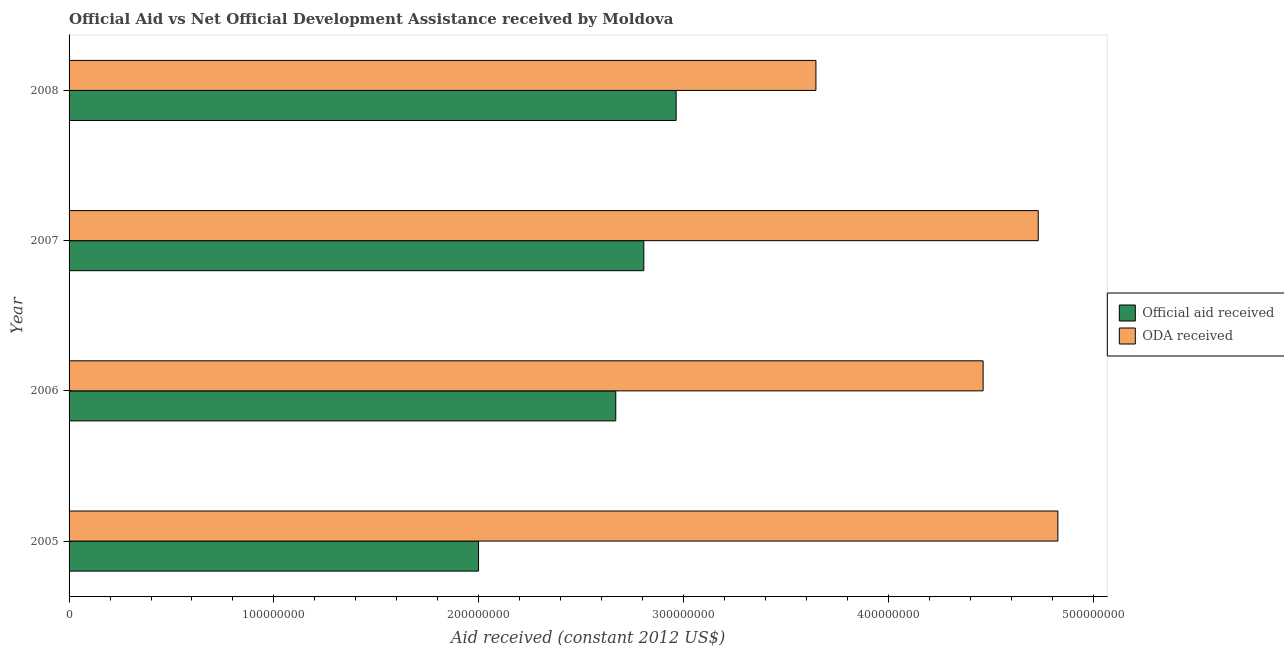How many different coloured bars are there?
Your answer should be compact. 2. How many groups of bars are there?
Your answer should be compact. 4. How many bars are there on the 4th tick from the top?
Your answer should be compact. 2. What is the oda received in 2005?
Make the answer very short. 4.83e+08. Across all years, what is the maximum official aid received?
Provide a succinct answer. 2.96e+08. Across all years, what is the minimum oda received?
Provide a succinct answer. 3.65e+08. In which year was the official aid received maximum?
Give a very brief answer. 2008. In which year was the oda received minimum?
Offer a terse response. 2008. What is the total official aid received in the graph?
Make the answer very short. 1.04e+09. What is the difference between the oda received in 2006 and that in 2008?
Offer a terse response. 8.16e+07. What is the difference between the oda received in 2007 and the official aid received in 2005?
Offer a terse response. 2.73e+08. What is the average official aid received per year?
Provide a succinct answer. 2.61e+08. In the year 2006, what is the difference between the official aid received and oda received?
Your answer should be compact. -1.79e+08. In how many years, is the official aid received greater than 160000000 US$?
Keep it short and to the point. 4. What is the ratio of the oda received in 2005 to that in 2007?
Provide a succinct answer. 1.02. What is the difference between the highest and the second highest official aid received?
Offer a very short reply. 1.58e+07. What is the difference between the highest and the lowest oda received?
Your response must be concise. 1.18e+08. In how many years, is the official aid received greater than the average official aid received taken over all years?
Give a very brief answer. 3. What does the 1st bar from the top in 2006 represents?
Give a very brief answer. ODA received. What does the 2nd bar from the bottom in 2008 represents?
Ensure brevity in your answer.  ODA received. How many bars are there?
Make the answer very short. 8. Does the graph contain any zero values?
Keep it short and to the point. No. Does the graph contain grids?
Keep it short and to the point. No. Where does the legend appear in the graph?
Your answer should be compact. Center right. How many legend labels are there?
Provide a short and direct response. 2. How are the legend labels stacked?
Your answer should be very brief. Vertical. What is the title of the graph?
Offer a very short reply. Official Aid vs Net Official Development Assistance received by Moldova . What is the label or title of the X-axis?
Ensure brevity in your answer.  Aid received (constant 2012 US$). What is the Aid received (constant 2012 US$) of Official aid received in 2005?
Offer a very short reply. 2.00e+08. What is the Aid received (constant 2012 US$) of ODA received in 2005?
Give a very brief answer. 4.83e+08. What is the Aid received (constant 2012 US$) of Official aid received in 2006?
Provide a short and direct response. 2.67e+08. What is the Aid received (constant 2012 US$) of ODA received in 2006?
Your response must be concise. 4.46e+08. What is the Aid received (constant 2012 US$) of Official aid received in 2007?
Your answer should be very brief. 2.81e+08. What is the Aid received (constant 2012 US$) of ODA received in 2007?
Your answer should be very brief. 4.73e+08. What is the Aid received (constant 2012 US$) of Official aid received in 2008?
Provide a short and direct response. 2.96e+08. What is the Aid received (constant 2012 US$) of ODA received in 2008?
Your response must be concise. 3.65e+08. Across all years, what is the maximum Aid received (constant 2012 US$) of Official aid received?
Your answer should be very brief. 2.96e+08. Across all years, what is the maximum Aid received (constant 2012 US$) in ODA received?
Offer a very short reply. 4.83e+08. Across all years, what is the minimum Aid received (constant 2012 US$) of Official aid received?
Your response must be concise. 2.00e+08. Across all years, what is the minimum Aid received (constant 2012 US$) in ODA received?
Your answer should be compact. 3.65e+08. What is the total Aid received (constant 2012 US$) in Official aid received in the graph?
Offer a terse response. 1.04e+09. What is the total Aid received (constant 2012 US$) of ODA received in the graph?
Give a very brief answer. 1.77e+09. What is the difference between the Aid received (constant 2012 US$) of Official aid received in 2005 and that in 2006?
Give a very brief answer. -6.70e+07. What is the difference between the Aid received (constant 2012 US$) in ODA received in 2005 and that in 2006?
Your answer should be very brief. 3.65e+07. What is the difference between the Aid received (constant 2012 US$) of Official aid received in 2005 and that in 2007?
Offer a terse response. -8.07e+07. What is the difference between the Aid received (constant 2012 US$) in ODA received in 2005 and that in 2007?
Make the answer very short. 9.58e+06. What is the difference between the Aid received (constant 2012 US$) in Official aid received in 2005 and that in 2008?
Give a very brief answer. -9.65e+07. What is the difference between the Aid received (constant 2012 US$) of ODA received in 2005 and that in 2008?
Keep it short and to the point. 1.18e+08. What is the difference between the Aid received (constant 2012 US$) in Official aid received in 2006 and that in 2007?
Offer a very short reply. -1.37e+07. What is the difference between the Aid received (constant 2012 US$) in ODA received in 2006 and that in 2007?
Your answer should be very brief. -2.69e+07. What is the difference between the Aid received (constant 2012 US$) of Official aid received in 2006 and that in 2008?
Your response must be concise. -2.95e+07. What is the difference between the Aid received (constant 2012 US$) of ODA received in 2006 and that in 2008?
Give a very brief answer. 8.16e+07. What is the difference between the Aid received (constant 2012 US$) of Official aid received in 2007 and that in 2008?
Offer a terse response. -1.58e+07. What is the difference between the Aid received (constant 2012 US$) in ODA received in 2007 and that in 2008?
Your answer should be very brief. 1.09e+08. What is the difference between the Aid received (constant 2012 US$) in Official aid received in 2005 and the Aid received (constant 2012 US$) in ODA received in 2006?
Your answer should be very brief. -2.46e+08. What is the difference between the Aid received (constant 2012 US$) of Official aid received in 2005 and the Aid received (constant 2012 US$) of ODA received in 2007?
Keep it short and to the point. -2.73e+08. What is the difference between the Aid received (constant 2012 US$) of Official aid received in 2005 and the Aid received (constant 2012 US$) of ODA received in 2008?
Give a very brief answer. -1.65e+08. What is the difference between the Aid received (constant 2012 US$) of Official aid received in 2006 and the Aid received (constant 2012 US$) of ODA received in 2007?
Offer a terse response. -2.06e+08. What is the difference between the Aid received (constant 2012 US$) of Official aid received in 2006 and the Aid received (constant 2012 US$) of ODA received in 2008?
Keep it short and to the point. -9.77e+07. What is the difference between the Aid received (constant 2012 US$) of Official aid received in 2007 and the Aid received (constant 2012 US$) of ODA received in 2008?
Provide a short and direct response. -8.40e+07. What is the average Aid received (constant 2012 US$) in Official aid received per year?
Provide a succinct answer. 2.61e+08. What is the average Aid received (constant 2012 US$) of ODA received per year?
Ensure brevity in your answer.  4.42e+08. In the year 2005, what is the difference between the Aid received (constant 2012 US$) of Official aid received and Aid received (constant 2012 US$) of ODA received?
Offer a very short reply. -2.83e+08. In the year 2006, what is the difference between the Aid received (constant 2012 US$) of Official aid received and Aid received (constant 2012 US$) of ODA received?
Provide a short and direct response. -1.79e+08. In the year 2007, what is the difference between the Aid received (constant 2012 US$) in Official aid received and Aid received (constant 2012 US$) in ODA received?
Your answer should be very brief. -1.93e+08. In the year 2008, what is the difference between the Aid received (constant 2012 US$) in Official aid received and Aid received (constant 2012 US$) in ODA received?
Keep it short and to the point. -6.82e+07. What is the ratio of the Aid received (constant 2012 US$) of Official aid received in 2005 to that in 2006?
Offer a terse response. 0.75. What is the ratio of the Aid received (constant 2012 US$) in ODA received in 2005 to that in 2006?
Ensure brevity in your answer.  1.08. What is the ratio of the Aid received (constant 2012 US$) in Official aid received in 2005 to that in 2007?
Provide a short and direct response. 0.71. What is the ratio of the Aid received (constant 2012 US$) of ODA received in 2005 to that in 2007?
Make the answer very short. 1.02. What is the ratio of the Aid received (constant 2012 US$) of Official aid received in 2005 to that in 2008?
Make the answer very short. 0.67. What is the ratio of the Aid received (constant 2012 US$) of ODA received in 2005 to that in 2008?
Make the answer very short. 1.32. What is the ratio of the Aid received (constant 2012 US$) in Official aid received in 2006 to that in 2007?
Your response must be concise. 0.95. What is the ratio of the Aid received (constant 2012 US$) in ODA received in 2006 to that in 2007?
Offer a terse response. 0.94. What is the ratio of the Aid received (constant 2012 US$) in Official aid received in 2006 to that in 2008?
Offer a terse response. 0.9. What is the ratio of the Aid received (constant 2012 US$) of ODA received in 2006 to that in 2008?
Ensure brevity in your answer.  1.22. What is the ratio of the Aid received (constant 2012 US$) of Official aid received in 2007 to that in 2008?
Offer a very short reply. 0.95. What is the ratio of the Aid received (constant 2012 US$) of ODA received in 2007 to that in 2008?
Give a very brief answer. 1.3. What is the difference between the highest and the second highest Aid received (constant 2012 US$) in Official aid received?
Provide a short and direct response. 1.58e+07. What is the difference between the highest and the second highest Aid received (constant 2012 US$) of ODA received?
Give a very brief answer. 9.58e+06. What is the difference between the highest and the lowest Aid received (constant 2012 US$) of Official aid received?
Your answer should be compact. 9.65e+07. What is the difference between the highest and the lowest Aid received (constant 2012 US$) in ODA received?
Offer a very short reply. 1.18e+08. 